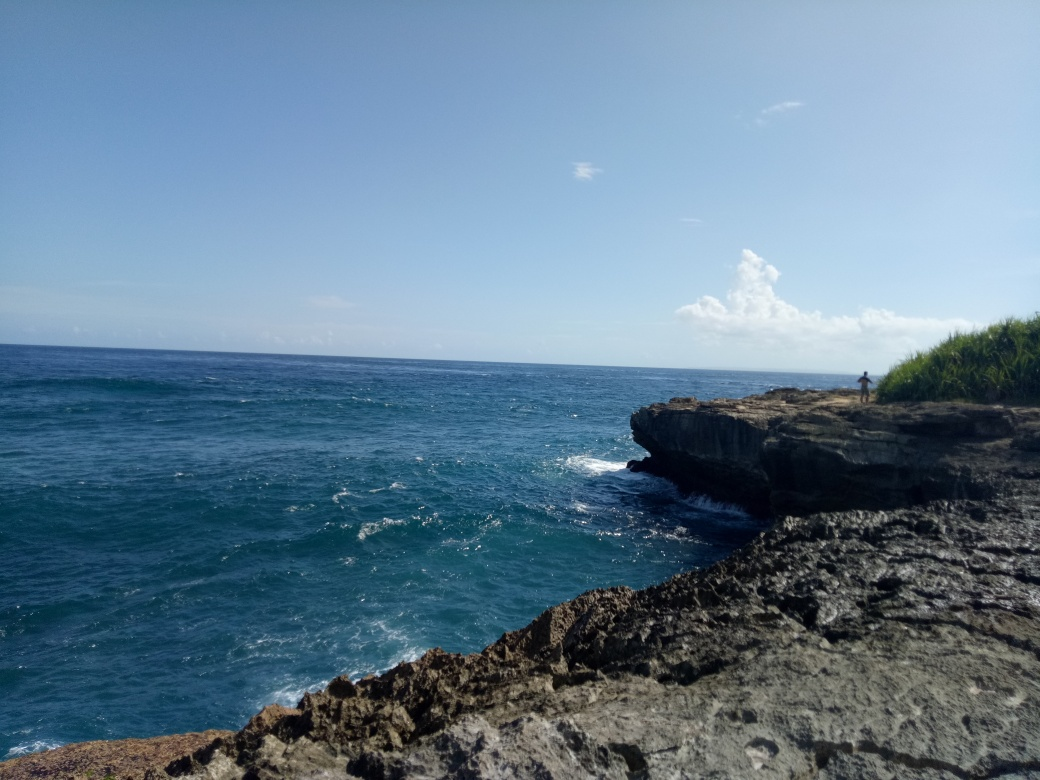Is the image of high quality? The image is of moderate quality. It captures the rugged beauty of the coastline and the clear blue waters with a good resolution. However, there is room for improvement in terms of composition and lighting to enhance its overall visual appeal. 